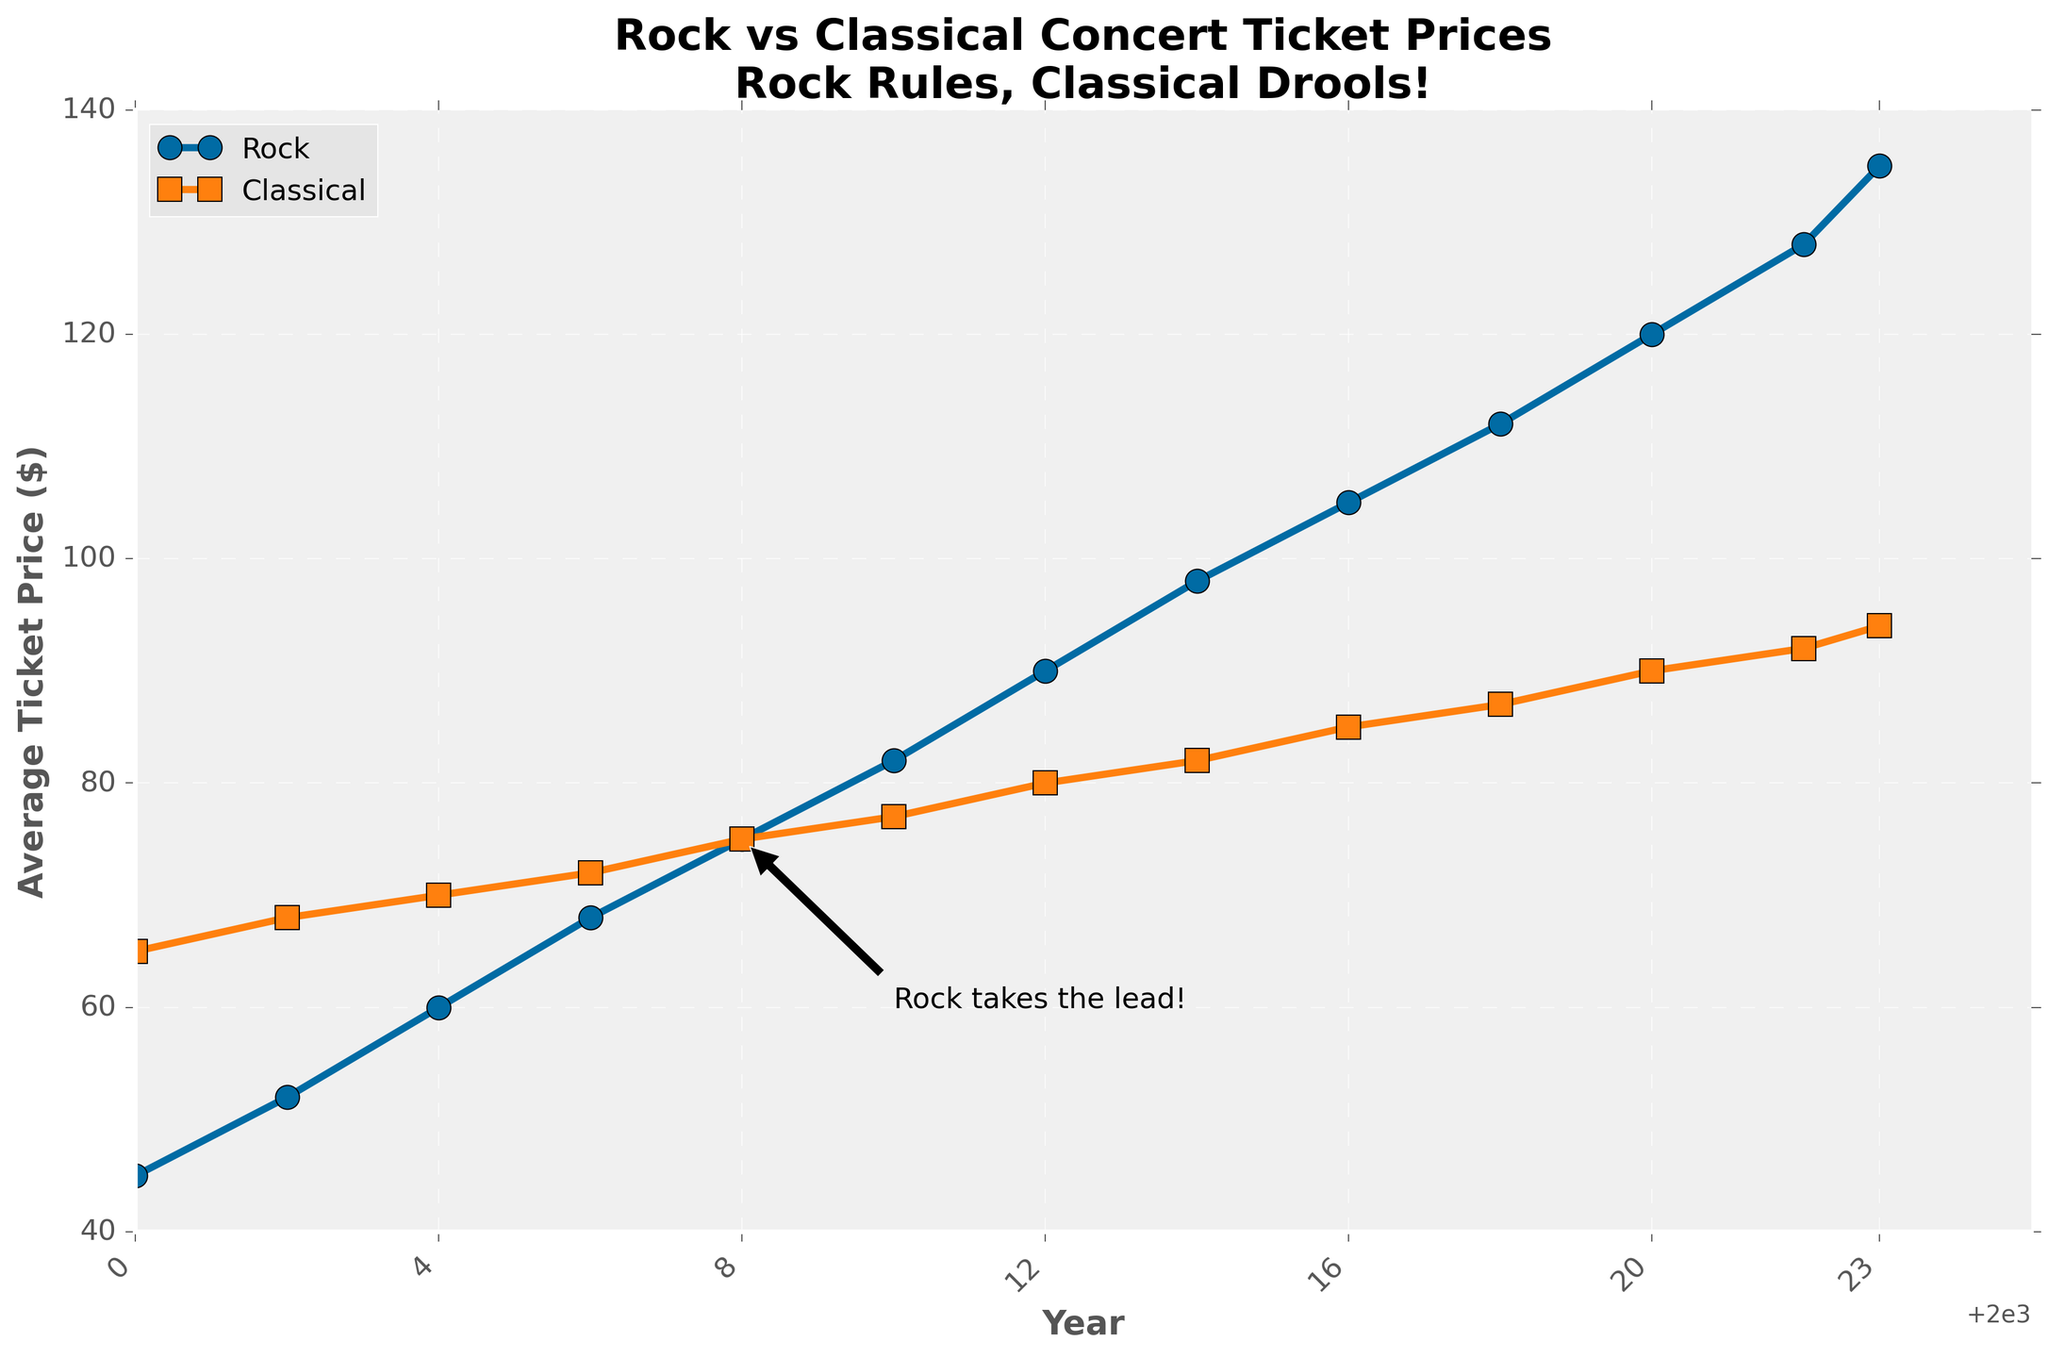Which type of concert had a higher average ticket price in 2000? In the figure, look at the data points for the year 2000. The average ticket price for rock concerts is $45, whereas for classical concerts it is $65, so classical concerts were higher.
Answer: Classical concerts By how much did the average ticket price for rock concerts increase from 2000 to 2023? To find the increase, subtract the 2000 value from the 2023 value for rock concerts. The 2023 value is $135 and the 2000 value is $45. Therefore, the increase is 135 - 45 = $90.
Answer: $90 In which year did rock concert ticket prices surpass classical concert ticket prices? Examine the lines and find the year where the rock line starts to stay consistently above the classical line. It happens around 2008, where rock concert ticket prices ($75) surpass classical concert ticket prices ($75).
Answer: 2008 What is the average ticket price for classical concerts in the last five years (2018-2023)? Find the classical concert prices for years 2018, 2020, 2022, and 2023: $87, $90, $92, and $94 respectively. Calculate the average: (87+90+92+94)/4 = 90.75.
Answer: $90.75 In which year did both rock and classical concert ticket prices reach $75? Look at the intersection point of the two lines where both prices are $75, which occurs in the year 2008.
Answer: 2008 How many years did it take for rock concert ticket prices to increase from $45 to $90? Check the years corresponding to $45 (2000) and $90 (2012) on the rock concert line. Subtract the initial year from the final year: 2012 - 2000 = 12 years.
Answer: 12 years What is the ratio of the average ticket price of rock concerts to classical concerts in 2023? Divide the average ticket price of rock concerts in 2023 by that of classical concerts: 135 / 94. The ratio is approximately 1.44.
Answer: 1.44 By how much did the average ticket price for classical concerts increase from 2002 to 2023? Subtract the classical concert price in 2002 from the price in 2023: 94 - 68 = $26.
Answer: $26 Which type of concert saw a more significant rate of increase in average ticket prices between 2000 and 2023? Calculate the increase for both rock and classical concerts over these years: Rock: 135 - 45 = $90, Classical: 94 - 65 = $29. Since $90 is greater than $29, rock concerts saw a more significant increase.
Answer: Rock concerts 